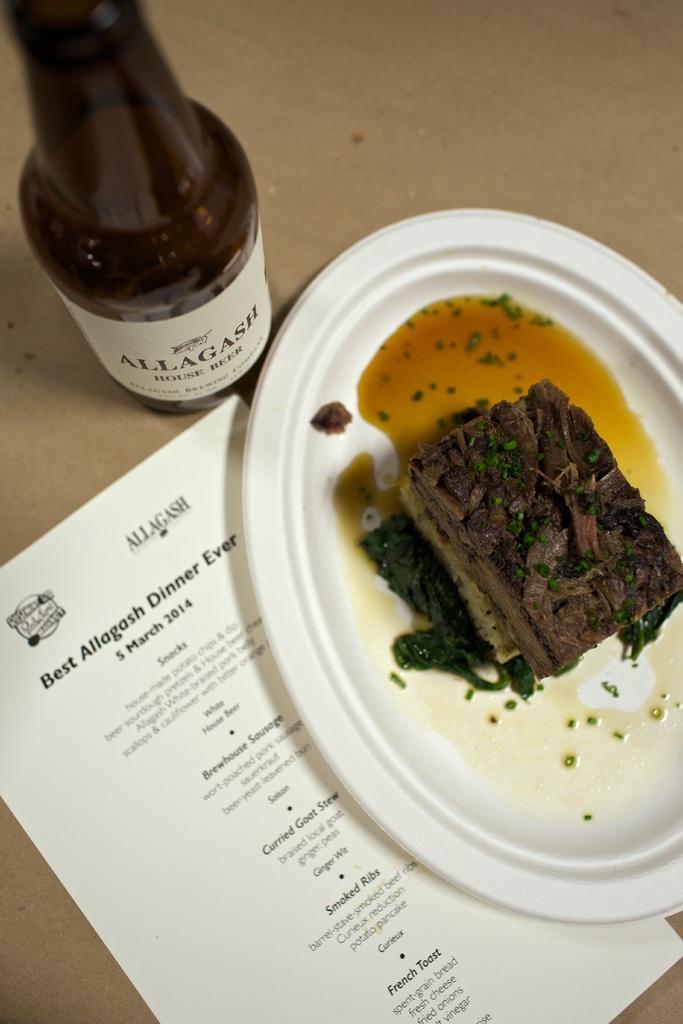Could you give a brief overview of what you see in this image? A picture of a food, it is presented in a plate. Beside this place there is a paper with information. A bottle. 